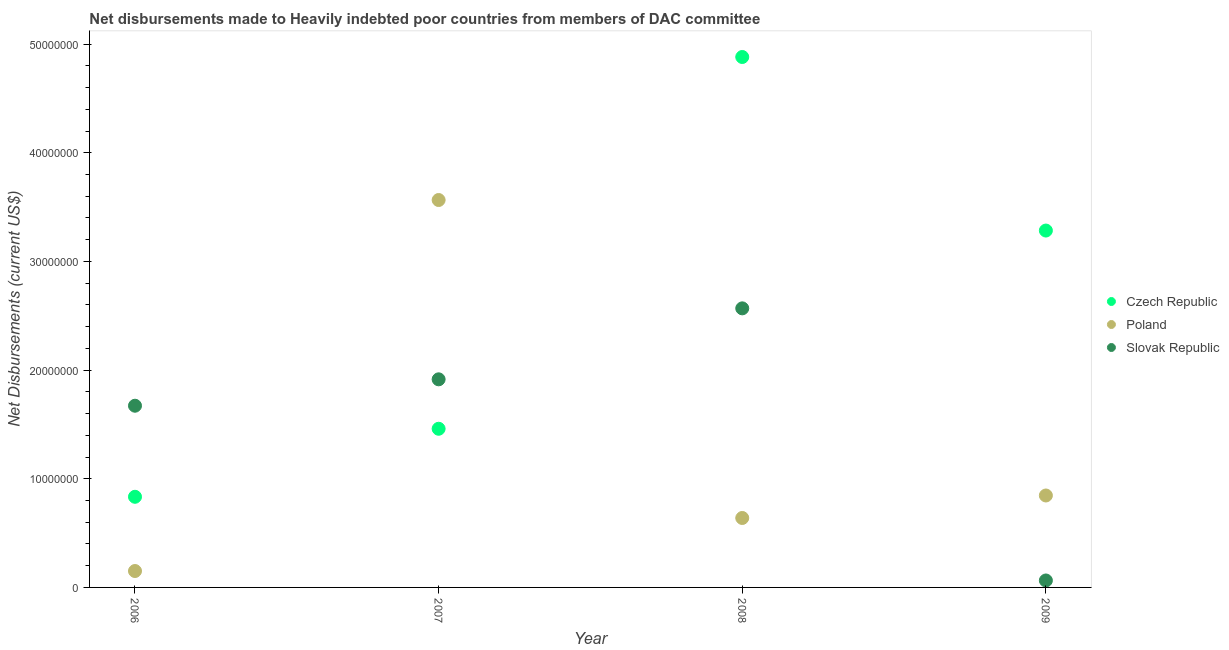How many different coloured dotlines are there?
Provide a short and direct response. 3. Is the number of dotlines equal to the number of legend labels?
Offer a very short reply. Yes. What is the net disbursements made by czech republic in 2006?
Provide a short and direct response. 8.34e+06. Across all years, what is the maximum net disbursements made by czech republic?
Your answer should be very brief. 4.88e+07. Across all years, what is the minimum net disbursements made by czech republic?
Keep it short and to the point. 8.34e+06. In which year was the net disbursements made by czech republic maximum?
Your answer should be compact. 2008. In which year was the net disbursements made by poland minimum?
Offer a very short reply. 2006. What is the total net disbursements made by slovak republic in the graph?
Provide a short and direct response. 6.22e+07. What is the difference between the net disbursements made by czech republic in 2006 and that in 2008?
Keep it short and to the point. -4.05e+07. What is the difference between the net disbursements made by slovak republic in 2007 and the net disbursements made by czech republic in 2009?
Your response must be concise. -1.37e+07. What is the average net disbursements made by poland per year?
Make the answer very short. 1.30e+07. In the year 2006, what is the difference between the net disbursements made by czech republic and net disbursements made by poland?
Keep it short and to the point. 6.83e+06. In how many years, is the net disbursements made by slovak republic greater than 36000000 US$?
Your response must be concise. 0. What is the ratio of the net disbursements made by poland in 2008 to that in 2009?
Provide a succinct answer. 0.76. Is the net disbursements made by czech republic in 2006 less than that in 2009?
Provide a short and direct response. Yes. Is the difference between the net disbursements made by czech republic in 2006 and 2008 greater than the difference between the net disbursements made by slovak republic in 2006 and 2008?
Your response must be concise. No. What is the difference between the highest and the second highest net disbursements made by slovak republic?
Keep it short and to the point. 6.53e+06. What is the difference between the highest and the lowest net disbursements made by slovak republic?
Make the answer very short. 2.50e+07. Is the sum of the net disbursements made by slovak republic in 2006 and 2009 greater than the maximum net disbursements made by poland across all years?
Give a very brief answer. No. Is it the case that in every year, the sum of the net disbursements made by czech republic and net disbursements made by poland is greater than the net disbursements made by slovak republic?
Provide a succinct answer. No. Does the net disbursements made by slovak republic monotonically increase over the years?
Give a very brief answer. No. Does the graph contain any zero values?
Provide a short and direct response. No. Does the graph contain grids?
Make the answer very short. No. What is the title of the graph?
Your answer should be very brief. Net disbursements made to Heavily indebted poor countries from members of DAC committee. Does "Infant(male)" appear as one of the legend labels in the graph?
Your response must be concise. No. What is the label or title of the X-axis?
Your answer should be compact. Year. What is the label or title of the Y-axis?
Your answer should be very brief. Net Disbursements (current US$). What is the Net Disbursements (current US$) of Czech Republic in 2006?
Keep it short and to the point. 8.34e+06. What is the Net Disbursements (current US$) of Poland in 2006?
Offer a terse response. 1.51e+06. What is the Net Disbursements (current US$) in Slovak Republic in 2006?
Your answer should be very brief. 1.67e+07. What is the Net Disbursements (current US$) in Czech Republic in 2007?
Provide a short and direct response. 1.46e+07. What is the Net Disbursements (current US$) in Poland in 2007?
Provide a succinct answer. 3.56e+07. What is the Net Disbursements (current US$) of Slovak Republic in 2007?
Give a very brief answer. 1.92e+07. What is the Net Disbursements (current US$) in Czech Republic in 2008?
Your answer should be very brief. 4.88e+07. What is the Net Disbursements (current US$) of Poland in 2008?
Offer a terse response. 6.39e+06. What is the Net Disbursements (current US$) of Slovak Republic in 2008?
Provide a short and direct response. 2.57e+07. What is the Net Disbursements (current US$) of Czech Republic in 2009?
Offer a very short reply. 3.28e+07. What is the Net Disbursements (current US$) in Poland in 2009?
Make the answer very short. 8.46e+06. What is the Net Disbursements (current US$) in Slovak Republic in 2009?
Offer a terse response. 6.40e+05. Across all years, what is the maximum Net Disbursements (current US$) in Czech Republic?
Your answer should be very brief. 4.88e+07. Across all years, what is the maximum Net Disbursements (current US$) of Poland?
Ensure brevity in your answer.  3.56e+07. Across all years, what is the maximum Net Disbursements (current US$) of Slovak Republic?
Your answer should be very brief. 2.57e+07. Across all years, what is the minimum Net Disbursements (current US$) of Czech Republic?
Make the answer very short. 8.34e+06. Across all years, what is the minimum Net Disbursements (current US$) in Poland?
Keep it short and to the point. 1.51e+06. Across all years, what is the minimum Net Disbursements (current US$) of Slovak Republic?
Give a very brief answer. 6.40e+05. What is the total Net Disbursements (current US$) of Czech Republic in the graph?
Your response must be concise. 1.05e+08. What is the total Net Disbursements (current US$) in Poland in the graph?
Your answer should be compact. 5.20e+07. What is the total Net Disbursements (current US$) in Slovak Republic in the graph?
Your response must be concise. 6.22e+07. What is the difference between the Net Disbursements (current US$) of Czech Republic in 2006 and that in 2007?
Keep it short and to the point. -6.26e+06. What is the difference between the Net Disbursements (current US$) of Poland in 2006 and that in 2007?
Your answer should be very brief. -3.41e+07. What is the difference between the Net Disbursements (current US$) of Slovak Republic in 2006 and that in 2007?
Your answer should be compact. -2.43e+06. What is the difference between the Net Disbursements (current US$) of Czech Republic in 2006 and that in 2008?
Provide a succinct answer. -4.05e+07. What is the difference between the Net Disbursements (current US$) of Poland in 2006 and that in 2008?
Give a very brief answer. -4.88e+06. What is the difference between the Net Disbursements (current US$) of Slovak Republic in 2006 and that in 2008?
Offer a terse response. -8.96e+06. What is the difference between the Net Disbursements (current US$) of Czech Republic in 2006 and that in 2009?
Provide a short and direct response. -2.45e+07. What is the difference between the Net Disbursements (current US$) of Poland in 2006 and that in 2009?
Your answer should be compact. -6.95e+06. What is the difference between the Net Disbursements (current US$) in Slovak Republic in 2006 and that in 2009?
Your answer should be compact. 1.61e+07. What is the difference between the Net Disbursements (current US$) of Czech Republic in 2007 and that in 2008?
Provide a short and direct response. -3.42e+07. What is the difference between the Net Disbursements (current US$) in Poland in 2007 and that in 2008?
Make the answer very short. 2.93e+07. What is the difference between the Net Disbursements (current US$) of Slovak Republic in 2007 and that in 2008?
Make the answer very short. -6.53e+06. What is the difference between the Net Disbursements (current US$) in Czech Republic in 2007 and that in 2009?
Keep it short and to the point. -1.82e+07. What is the difference between the Net Disbursements (current US$) in Poland in 2007 and that in 2009?
Provide a short and direct response. 2.72e+07. What is the difference between the Net Disbursements (current US$) in Slovak Republic in 2007 and that in 2009?
Keep it short and to the point. 1.85e+07. What is the difference between the Net Disbursements (current US$) in Czech Republic in 2008 and that in 2009?
Your answer should be very brief. 1.60e+07. What is the difference between the Net Disbursements (current US$) of Poland in 2008 and that in 2009?
Provide a succinct answer. -2.07e+06. What is the difference between the Net Disbursements (current US$) in Slovak Republic in 2008 and that in 2009?
Keep it short and to the point. 2.50e+07. What is the difference between the Net Disbursements (current US$) of Czech Republic in 2006 and the Net Disbursements (current US$) of Poland in 2007?
Offer a terse response. -2.73e+07. What is the difference between the Net Disbursements (current US$) of Czech Republic in 2006 and the Net Disbursements (current US$) of Slovak Republic in 2007?
Your answer should be compact. -1.08e+07. What is the difference between the Net Disbursements (current US$) of Poland in 2006 and the Net Disbursements (current US$) of Slovak Republic in 2007?
Your answer should be compact. -1.76e+07. What is the difference between the Net Disbursements (current US$) in Czech Republic in 2006 and the Net Disbursements (current US$) in Poland in 2008?
Keep it short and to the point. 1.95e+06. What is the difference between the Net Disbursements (current US$) of Czech Republic in 2006 and the Net Disbursements (current US$) of Slovak Republic in 2008?
Your response must be concise. -1.73e+07. What is the difference between the Net Disbursements (current US$) in Poland in 2006 and the Net Disbursements (current US$) in Slovak Republic in 2008?
Offer a very short reply. -2.42e+07. What is the difference between the Net Disbursements (current US$) of Czech Republic in 2006 and the Net Disbursements (current US$) of Slovak Republic in 2009?
Offer a terse response. 7.70e+06. What is the difference between the Net Disbursements (current US$) in Poland in 2006 and the Net Disbursements (current US$) in Slovak Republic in 2009?
Keep it short and to the point. 8.70e+05. What is the difference between the Net Disbursements (current US$) in Czech Republic in 2007 and the Net Disbursements (current US$) in Poland in 2008?
Provide a succinct answer. 8.21e+06. What is the difference between the Net Disbursements (current US$) in Czech Republic in 2007 and the Net Disbursements (current US$) in Slovak Republic in 2008?
Keep it short and to the point. -1.11e+07. What is the difference between the Net Disbursements (current US$) of Poland in 2007 and the Net Disbursements (current US$) of Slovak Republic in 2008?
Your answer should be very brief. 9.97e+06. What is the difference between the Net Disbursements (current US$) of Czech Republic in 2007 and the Net Disbursements (current US$) of Poland in 2009?
Your response must be concise. 6.14e+06. What is the difference between the Net Disbursements (current US$) of Czech Republic in 2007 and the Net Disbursements (current US$) of Slovak Republic in 2009?
Ensure brevity in your answer.  1.40e+07. What is the difference between the Net Disbursements (current US$) in Poland in 2007 and the Net Disbursements (current US$) in Slovak Republic in 2009?
Provide a short and direct response. 3.50e+07. What is the difference between the Net Disbursements (current US$) of Czech Republic in 2008 and the Net Disbursements (current US$) of Poland in 2009?
Offer a terse response. 4.04e+07. What is the difference between the Net Disbursements (current US$) of Czech Republic in 2008 and the Net Disbursements (current US$) of Slovak Republic in 2009?
Give a very brief answer. 4.82e+07. What is the difference between the Net Disbursements (current US$) of Poland in 2008 and the Net Disbursements (current US$) of Slovak Republic in 2009?
Make the answer very short. 5.75e+06. What is the average Net Disbursements (current US$) of Czech Republic per year?
Give a very brief answer. 2.61e+07. What is the average Net Disbursements (current US$) in Poland per year?
Your answer should be compact. 1.30e+07. What is the average Net Disbursements (current US$) of Slovak Republic per year?
Provide a succinct answer. 1.55e+07. In the year 2006, what is the difference between the Net Disbursements (current US$) in Czech Republic and Net Disbursements (current US$) in Poland?
Your answer should be very brief. 6.83e+06. In the year 2006, what is the difference between the Net Disbursements (current US$) in Czech Republic and Net Disbursements (current US$) in Slovak Republic?
Provide a succinct answer. -8.38e+06. In the year 2006, what is the difference between the Net Disbursements (current US$) in Poland and Net Disbursements (current US$) in Slovak Republic?
Your answer should be compact. -1.52e+07. In the year 2007, what is the difference between the Net Disbursements (current US$) in Czech Republic and Net Disbursements (current US$) in Poland?
Make the answer very short. -2.10e+07. In the year 2007, what is the difference between the Net Disbursements (current US$) in Czech Republic and Net Disbursements (current US$) in Slovak Republic?
Ensure brevity in your answer.  -4.55e+06. In the year 2007, what is the difference between the Net Disbursements (current US$) of Poland and Net Disbursements (current US$) of Slovak Republic?
Your response must be concise. 1.65e+07. In the year 2008, what is the difference between the Net Disbursements (current US$) in Czech Republic and Net Disbursements (current US$) in Poland?
Provide a short and direct response. 4.24e+07. In the year 2008, what is the difference between the Net Disbursements (current US$) in Czech Republic and Net Disbursements (current US$) in Slovak Republic?
Your answer should be very brief. 2.31e+07. In the year 2008, what is the difference between the Net Disbursements (current US$) in Poland and Net Disbursements (current US$) in Slovak Republic?
Provide a succinct answer. -1.93e+07. In the year 2009, what is the difference between the Net Disbursements (current US$) of Czech Republic and Net Disbursements (current US$) of Poland?
Provide a succinct answer. 2.44e+07. In the year 2009, what is the difference between the Net Disbursements (current US$) of Czech Republic and Net Disbursements (current US$) of Slovak Republic?
Your answer should be very brief. 3.22e+07. In the year 2009, what is the difference between the Net Disbursements (current US$) of Poland and Net Disbursements (current US$) of Slovak Republic?
Keep it short and to the point. 7.82e+06. What is the ratio of the Net Disbursements (current US$) of Czech Republic in 2006 to that in 2007?
Ensure brevity in your answer.  0.57. What is the ratio of the Net Disbursements (current US$) of Poland in 2006 to that in 2007?
Provide a succinct answer. 0.04. What is the ratio of the Net Disbursements (current US$) in Slovak Republic in 2006 to that in 2007?
Your answer should be compact. 0.87. What is the ratio of the Net Disbursements (current US$) in Czech Republic in 2006 to that in 2008?
Make the answer very short. 0.17. What is the ratio of the Net Disbursements (current US$) in Poland in 2006 to that in 2008?
Provide a short and direct response. 0.24. What is the ratio of the Net Disbursements (current US$) of Slovak Republic in 2006 to that in 2008?
Your response must be concise. 0.65. What is the ratio of the Net Disbursements (current US$) of Czech Republic in 2006 to that in 2009?
Provide a short and direct response. 0.25. What is the ratio of the Net Disbursements (current US$) in Poland in 2006 to that in 2009?
Keep it short and to the point. 0.18. What is the ratio of the Net Disbursements (current US$) of Slovak Republic in 2006 to that in 2009?
Ensure brevity in your answer.  26.12. What is the ratio of the Net Disbursements (current US$) in Czech Republic in 2007 to that in 2008?
Your response must be concise. 0.3. What is the ratio of the Net Disbursements (current US$) of Poland in 2007 to that in 2008?
Offer a very short reply. 5.58. What is the ratio of the Net Disbursements (current US$) in Slovak Republic in 2007 to that in 2008?
Offer a very short reply. 0.75. What is the ratio of the Net Disbursements (current US$) in Czech Republic in 2007 to that in 2009?
Your response must be concise. 0.44. What is the ratio of the Net Disbursements (current US$) in Poland in 2007 to that in 2009?
Make the answer very short. 4.21. What is the ratio of the Net Disbursements (current US$) in Slovak Republic in 2007 to that in 2009?
Make the answer very short. 29.92. What is the ratio of the Net Disbursements (current US$) of Czech Republic in 2008 to that in 2009?
Give a very brief answer. 1.49. What is the ratio of the Net Disbursements (current US$) of Poland in 2008 to that in 2009?
Offer a terse response. 0.76. What is the ratio of the Net Disbursements (current US$) of Slovak Republic in 2008 to that in 2009?
Provide a succinct answer. 40.12. What is the difference between the highest and the second highest Net Disbursements (current US$) of Czech Republic?
Ensure brevity in your answer.  1.60e+07. What is the difference between the highest and the second highest Net Disbursements (current US$) in Poland?
Your answer should be very brief. 2.72e+07. What is the difference between the highest and the second highest Net Disbursements (current US$) in Slovak Republic?
Provide a succinct answer. 6.53e+06. What is the difference between the highest and the lowest Net Disbursements (current US$) of Czech Republic?
Your answer should be compact. 4.05e+07. What is the difference between the highest and the lowest Net Disbursements (current US$) of Poland?
Make the answer very short. 3.41e+07. What is the difference between the highest and the lowest Net Disbursements (current US$) in Slovak Republic?
Provide a short and direct response. 2.50e+07. 